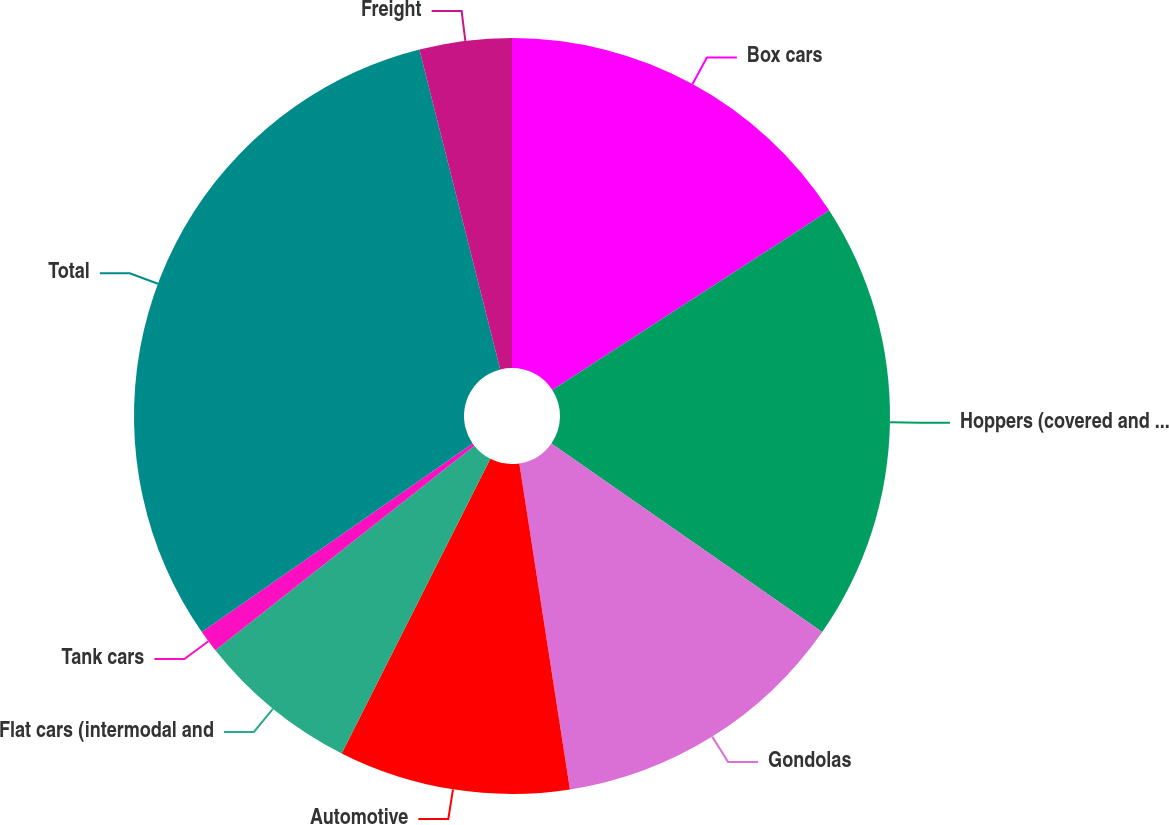Convert chart. <chart><loc_0><loc_0><loc_500><loc_500><pie_chart><fcel>Box cars<fcel>Hoppers (covered and open top)<fcel>Gondolas<fcel>Automotive<fcel>Flat cars (intermodal and<fcel>Tank cars<fcel>Total<fcel>Freight<nl><fcel>15.85%<fcel>18.83%<fcel>12.87%<fcel>9.89%<fcel>6.92%<fcel>0.96%<fcel>30.74%<fcel>3.94%<nl></chart> 